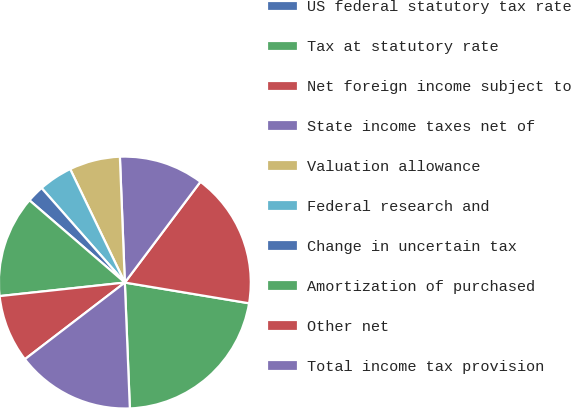<chart> <loc_0><loc_0><loc_500><loc_500><pie_chart><fcel>US federal statutory tax rate<fcel>Tax at statutory rate<fcel>Net foreign income subject to<fcel>State income taxes net of<fcel>Valuation allowance<fcel>Federal research and<fcel>Change in uncertain tax<fcel>Amortization of purchased<fcel>Other net<fcel>Total income tax provision<nl><fcel>0.0%<fcel>21.74%<fcel>17.39%<fcel>10.87%<fcel>6.52%<fcel>4.35%<fcel>2.18%<fcel>13.04%<fcel>8.7%<fcel>15.22%<nl></chart> 